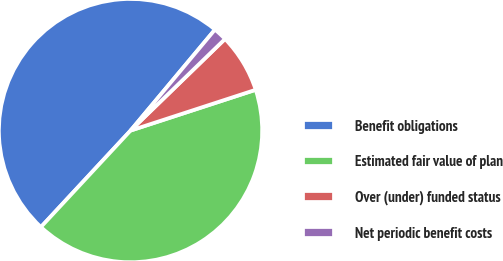Convert chart. <chart><loc_0><loc_0><loc_500><loc_500><pie_chart><fcel>Benefit obligations<fcel>Estimated fair value of plan<fcel>Over (under) funded status<fcel>Net periodic benefit costs<nl><fcel>49.17%<fcel>41.93%<fcel>7.24%<fcel>1.66%<nl></chart> 